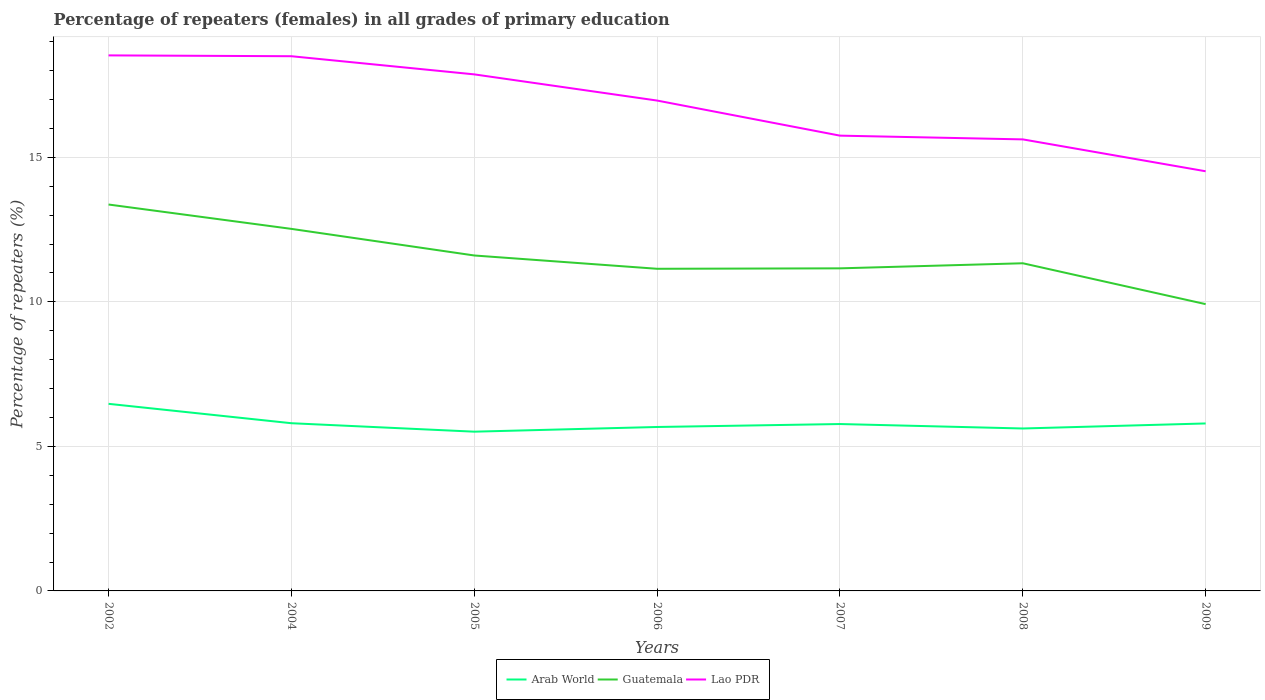How many different coloured lines are there?
Make the answer very short. 3. Is the number of lines equal to the number of legend labels?
Your answer should be very brief. Yes. Across all years, what is the maximum percentage of repeaters (females) in Arab World?
Your answer should be very brief. 5.51. What is the total percentage of repeaters (females) in Lao PDR in the graph?
Give a very brief answer. 1.23. What is the difference between the highest and the second highest percentage of repeaters (females) in Arab World?
Provide a succinct answer. 0.96. Is the percentage of repeaters (females) in Guatemala strictly greater than the percentage of repeaters (females) in Arab World over the years?
Provide a short and direct response. No. How many lines are there?
Give a very brief answer. 3. How many years are there in the graph?
Ensure brevity in your answer.  7. Does the graph contain grids?
Ensure brevity in your answer.  Yes. Where does the legend appear in the graph?
Give a very brief answer. Bottom center. What is the title of the graph?
Offer a very short reply. Percentage of repeaters (females) in all grades of primary education. What is the label or title of the Y-axis?
Make the answer very short. Percentage of repeaters (%). What is the Percentage of repeaters (%) of Arab World in 2002?
Offer a very short reply. 6.47. What is the Percentage of repeaters (%) in Guatemala in 2002?
Offer a terse response. 13.37. What is the Percentage of repeaters (%) of Lao PDR in 2002?
Offer a terse response. 18.53. What is the Percentage of repeaters (%) in Arab World in 2004?
Ensure brevity in your answer.  5.8. What is the Percentage of repeaters (%) of Guatemala in 2004?
Your answer should be compact. 12.52. What is the Percentage of repeaters (%) in Lao PDR in 2004?
Give a very brief answer. 18.5. What is the Percentage of repeaters (%) in Arab World in 2005?
Offer a terse response. 5.51. What is the Percentage of repeaters (%) in Guatemala in 2005?
Your answer should be very brief. 11.6. What is the Percentage of repeaters (%) in Lao PDR in 2005?
Keep it short and to the point. 17.87. What is the Percentage of repeaters (%) in Arab World in 2006?
Keep it short and to the point. 5.67. What is the Percentage of repeaters (%) of Guatemala in 2006?
Ensure brevity in your answer.  11.14. What is the Percentage of repeaters (%) in Lao PDR in 2006?
Give a very brief answer. 16.96. What is the Percentage of repeaters (%) of Arab World in 2007?
Your response must be concise. 5.77. What is the Percentage of repeaters (%) in Guatemala in 2007?
Provide a succinct answer. 11.16. What is the Percentage of repeaters (%) of Lao PDR in 2007?
Give a very brief answer. 15.75. What is the Percentage of repeaters (%) of Arab World in 2008?
Offer a terse response. 5.62. What is the Percentage of repeaters (%) of Guatemala in 2008?
Offer a very short reply. 11.33. What is the Percentage of repeaters (%) in Lao PDR in 2008?
Ensure brevity in your answer.  15.62. What is the Percentage of repeaters (%) in Arab World in 2009?
Provide a succinct answer. 5.79. What is the Percentage of repeaters (%) of Guatemala in 2009?
Your answer should be very brief. 9.92. What is the Percentage of repeaters (%) in Lao PDR in 2009?
Your answer should be compact. 14.52. Across all years, what is the maximum Percentage of repeaters (%) in Arab World?
Ensure brevity in your answer.  6.47. Across all years, what is the maximum Percentage of repeaters (%) of Guatemala?
Your answer should be very brief. 13.37. Across all years, what is the maximum Percentage of repeaters (%) of Lao PDR?
Ensure brevity in your answer.  18.53. Across all years, what is the minimum Percentage of repeaters (%) of Arab World?
Keep it short and to the point. 5.51. Across all years, what is the minimum Percentage of repeaters (%) in Guatemala?
Your response must be concise. 9.92. Across all years, what is the minimum Percentage of repeaters (%) of Lao PDR?
Provide a succinct answer. 14.52. What is the total Percentage of repeaters (%) of Arab World in the graph?
Your answer should be very brief. 40.64. What is the total Percentage of repeaters (%) in Guatemala in the graph?
Keep it short and to the point. 81.05. What is the total Percentage of repeaters (%) of Lao PDR in the graph?
Make the answer very short. 117.74. What is the difference between the Percentage of repeaters (%) of Arab World in 2002 and that in 2004?
Offer a terse response. 0.67. What is the difference between the Percentage of repeaters (%) in Guatemala in 2002 and that in 2004?
Offer a terse response. 0.84. What is the difference between the Percentage of repeaters (%) in Lao PDR in 2002 and that in 2004?
Make the answer very short. 0.03. What is the difference between the Percentage of repeaters (%) in Arab World in 2002 and that in 2005?
Give a very brief answer. 0.96. What is the difference between the Percentage of repeaters (%) in Guatemala in 2002 and that in 2005?
Offer a terse response. 1.76. What is the difference between the Percentage of repeaters (%) of Lao PDR in 2002 and that in 2005?
Offer a terse response. 0.66. What is the difference between the Percentage of repeaters (%) in Arab World in 2002 and that in 2006?
Your answer should be very brief. 0.8. What is the difference between the Percentage of repeaters (%) of Guatemala in 2002 and that in 2006?
Make the answer very short. 2.22. What is the difference between the Percentage of repeaters (%) of Lao PDR in 2002 and that in 2006?
Give a very brief answer. 1.56. What is the difference between the Percentage of repeaters (%) in Arab World in 2002 and that in 2007?
Keep it short and to the point. 0.7. What is the difference between the Percentage of repeaters (%) of Guatemala in 2002 and that in 2007?
Ensure brevity in your answer.  2.21. What is the difference between the Percentage of repeaters (%) in Lao PDR in 2002 and that in 2007?
Ensure brevity in your answer.  2.78. What is the difference between the Percentage of repeaters (%) of Arab World in 2002 and that in 2008?
Offer a terse response. 0.85. What is the difference between the Percentage of repeaters (%) in Guatemala in 2002 and that in 2008?
Offer a very short reply. 2.03. What is the difference between the Percentage of repeaters (%) of Lao PDR in 2002 and that in 2008?
Make the answer very short. 2.91. What is the difference between the Percentage of repeaters (%) in Arab World in 2002 and that in 2009?
Provide a succinct answer. 0.68. What is the difference between the Percentage of repeaters (%) in Guatemala in 2002 and that in 2009?
Keep it short and to the point. 3.45. What is the difference between the Percentage of repeaters (%) of Lao PDR in 2002 and that in 2009?
Give a very brief answer. 4.01. What is the difference between the Percentage of repeaters (%) in Arab World in 2004 and that in 2005?
Your answer should be very brief. 0.29. What is the difference between the Percentage of repeaters (%) in Guatemala in 2004 and that in 2005?
Keep it short and to the point. 0.92. What is the difference between the Percentage of repeaters (%) of Lao PDR in 2004 and that in 2005?
Offer a very short reply. 0.63. What is the difference between the Percentage of repeaters (%) in Arab World in 2004 and that in 2006?
Give a very brief answer. 0.13. What is the difference between the Percentage of repeaters (%) of Guatemala in 2004 and that in 2006?
Offer a terse response. 1.38. What is the difference between the Percentage of repeaters (%) of Lao PDR in 2004 and that in 2006?
Your response must be concise. 1.53. What is the difference between the Percentage of repeaters (%) in Arab World in 2004 and that in 2007?
Make the answer very short. 0.03. What is the difference between the Percentage of repeaters (%) in Guatemala in 2004 and that in 2007?
Make the answer very short. 1.37. What is the difference between the Percentage of repeaters (%) of Lao PDR in 2004 and that in 2007?
Keep it short and to the point. 2.75. What is the difference between the Percentage of repeaters (%) of Arab World in 2004 and that in 2008?
Offer a very short reply. 0.18. What is the difference between the Percentage of repeaters (%) in Guatemala in 2004 and that in 2008?
Offer a terse response. 1.19. What is the difference between the Percentage of repeaters (%) of Lao PDR in 2004 and that in 2008?
Provide a short and direct response. 2.88. What is the difference between the Percentage of repeaters (%) of Arab World in 2004 and that in 2009?
Make the answer very short. 0.01. What is the difference between the Percentage of repeaters (%) in Guatemala in 2004 and that in 2009?
Your response must be concise. 2.6. What is the difference between the Percentage of repeaters (%) in Lao PDR in 2004 and that in 2009?
Your response must be concise. 3.98. What is the difference between the Percentage of repeaters (%) in Arab World in 2005 and that in 2006?
Your response must be concise. -0.16. What is the difference between the Percentage of repeaters (%) of Guatemala in 2005 and that in 2006?
Your response must be concise. 0.46. What is the difference between the Percentage of repeaters (%) of Lao PDR in 2005 and that in 2006?
Your answer should be very brief. 0.91. What is the difference between the Percentage of repeaters (%) in Arab World in 2005 and that in 2007?
Ensure brevity in your answer.  -0.26. What is the difference between the Percentage of repeaters (%) of Guatemala in 2005 and that in 2007?
Provide a short and direct response. 0.45. What is the difference between the Percentage of repeaters (%) in Lao PDR in 2005 and that in 2007?
Your answer should be very brief. 2.12. What is the difference between the Percentage of repeaters (%) of Arab World in 2005 and that in 2008?
Provide a short and direct response. -0.11. What is the difference between the Percentage of repeaters (%) of Guatemala in 2005 and that in 2008?
Your answer should be very brief. 0.27. What is the difference between the Percentage of repeaters (%) of Lao PDR in 2005 and that in 2008?
Give a very brief answer. 2.25. What is the difference between the Percentage of repeaters (%) of Arab World in 2005 and that in 2009?
Ensure brevity in your answer.  -0.28. What is the difference between the Percentage of repeaters (%) of Guatemala in 2005 and that in 2009?
Keep it short and to the point. 1.68. What is the difference between the Percentage of repeaters (%) in Lao PDR in 2005 and that in 2009?
Give a very brief answer. 3.35. What is the difference between the Percentage of repeaters (%) of Arab World in 2006 and that in 2007?
Provide a short and direct response. -0.1. What is the difference between the Percentage of repeaters (%) in Guatemala in 2006 and that in 2007?
Your answer should be compact. -0.01. What is the difference between the Percentage of repeaters (%) of Lao PDR in 2006 and that in 2007?
Ensure brevity in your answer.  1.21. What is the difference between the Percentage of repeaters (%) of Arab World in 2006 and that in 2008?
Offer a very short reply. 0.05. What is the difference between the Percentage of repeaters (%) in Guatemala in 2006 and that in 2008?
Make the answer very short. -0.19. What is the difference between the Percentage of repeaters (%) in Lao PDR in 2006 and that in 2008?
Provide a short and direct response. 1.34. What is the difference between the Percentage of repeaters (%) in Arab World in 2006 and that in 2009?
Your response must be concise. -0.12. What is the difference between the Percentage of repeaters (%) in Guatemala in 2006 and that in 2009?
Your answer should be compact. 1.22. What is the difference between the Percentage of repeaters (%) of Lao PDR in 2006 and that in 2009?
Your answer should be compact. 2.45. What is the difference between the Percentage of repeaters (%) of Arab World in 2007 and that in 2008?
Provide a succinct answer. 0.15. What is the difference between the Percentage of repeaters (%) of Guatemala in 2007 and that in 2008?
Give a very brief answer. -0.18. What is the difference between the Percentage of repeaters (%) in Lao PDR in 2007 and that in 2008?
Provide a short and direct response. 0.13. What is the difference between the Percentage of repeaters (%) of Arab World in 2007 and that in 2009?
Offer a terse response. -0.02. What is the difference between the Percentage of repeaters (%) of Guatemala in 2007 and that in 2009?
Your response must be concise. 1.24. What is the difference between the Percentage of repeaters (%) in Lao PDR in 2007 and that in 2009?
Your answer should be very brief. 1.23. What is the difference between the Percentage of repeaters (%) of Arab World in 2008 and that in 2009?
Your response must be concise. -0.17. What is the difference between the Percentage of repeaters (%) of Guatemala in 2008 and that in 2009?
Provide a succinct answer. 1.41. What is the difference between the Percentage of repeaters (%) of Lao PDR in 2008 and that in 2009?
Ensure brevity in your answer.  1.1. What is the difference between the Percentage of repeaters (%) of Arab World in 2002 and the Percentage of repeaters (%) of Guatemala in 2004?
Ensure brevity in your answer.  -6.05. What is the difference between the Percentage of repeaters (%) of Arab World in 2002 and the Percentage of repeaters (%) of Lao PDR in 2004?
Keep it short and to the point. -12.02. What is the difference between the Percentage of repeaters (%) of Guatemala in 2002 and the Percentage of repeaters (%) of Lao PDR in 2004?
Your answer should be compact. -5.13. What is the difference between the Percentage of repeaters (%) of Arab World in 2002 and the Percentage of repeaters (%) of Guatemala in 2005?
Make the answer very short. -5.13. What is the difference between the Percentage of repeaters (%) of Arab World in 2002 and the Percentage of repeaters (%) of Lao PDR in 2005?
Offer a very short reply. -11.4. What is the difference between the Percentage of repeaters (%) of Guatemala in 2002 and the Percentage of repeaters (%) of Lao PDR in 2005?
Give a very brief answer. -4.5. What is the difference between the Percentage of repeaters (%) of Arab World in 2002 and the Percentage of repeaters (%) of Guatemala in 2006?
Ensure brevity in your answer.  -4.67. What is the difference between the Percentage of repeaters (%) of Arab World in 2002 and the Percentage of repeaters (%) of Lao PDR in 2006?
Keep it short and to the point. -10.49. What is the difference between the Percentage of repeaters (%) in Guatemala in 2002 and the Percentage of repeaters (%) in Lao PDR in 2006?
Provide a succinct answer. -3.6. What is the difference between the Percentage of repeaters (%) of Arab World in 2002 and the Percentage of repeaters (%) of Guatemala in 2007?
Your answer should be compact. -4.69. What is the difference between the Percentage of repeaters (%) of Arab World in 2002 and the Percentage of repeaters (%) of Lao PDR in 2007?
Your response must be concise. -9.28. What is the difference between the Percentage of repeaters (%) of Guatemala in 2002 and the Percentage of repeaters (%) of Lao PDR in 2007?
Your answer should be very brief. -2.38. What is the difference between the Percentage of repeaters (%) in Arab World in 2002 and the Percentage of repeaters (%) in Guatemala in 2008?
Keep it short and to the point. -4.86. What is the difference between the Percentage of repeaters (%) of Arab World in 2002 and the Percentage of repeaters (%) of Lao PDR in 2008?
Provide a short and direct response. -9.15. What is the difference between the Percentage of repeaters (%) of Guatemala in 2002 and the Percentage of repeaters (%) of Lao PDR in 2008?
Make the answer very short. -2.25. What is the difference between the Percentage of repeaters (%) in Arab World in 2002 and the Percentage of repeaters (%) in Guatemala in 2009?
Keep it short and to the point. -3.45. What is the difference between the Percentage of repeaters (%) of Arab World in 2002 and the Percentage of repeaters (%) of Lao PDR in 2009?
Your response must be concise. -8.04. What is the difference between the Percentage of repeaters (%) of Guatemala in 2002 and the Percentage of repeaters (%) of Lao PDR in 2009?
Keep it short and to the point. -1.15. What is the difference between the Percentage of repeaters (%) in Arab World in 2004 and the Percentage of repeaters (%) in Guatemala in 2005?
Offer a very short reply. -5.8. What is the difference between the Percentage of repeaters (%) of Arab World in 2004 and the Percentage of repeaters (%) of Lao PDR in 2005?
Offer a very short reply. -12.07. What is the difference between the Percentage of repeaters (%) of Guatemala in 2004 and the Percentage of repeaters (%) of Lao PDR in 2005?
Your answer should be very brief. -5.34. What is the difference between the Percentage of repeaters (%) in Arab World in 2004 and the Percentage of repeaters (%) in Guatemala in 2006?
Make the answer very short. -5.34. What is the difference between the Percentage of repeaters (%) of Arab World in 2004 and the Percentage of repeaters (%) of Lao PDR in 2006?
Provide a short and direct response. -11.16. What is the difference between the Percentage of repeaters (%) in Guatemala in 2004 and the Percentage of repeaters (%) in Lao PDR in 2006?
Offer a terse response. -4.44. What is the difference between the Percentage of repeaters (%) in Arab World in 2004 and the Percentage of repeaters (%) in Guatemala in 2007?
Provide a short and direct response. -5.36. What is the difference between the Percentage of repeaters (%) of Arab World in 2004 and the Percentage of repeaters (%) of Lao PDR in 2007?
Your answer should be very brief. -9.95. What is the difference between the Percentage of repeaters (%) in Guatemala in 2004 and the Percentage of repeaters (%) in Lao PDR in 2007?
Your response must be concise. -3.23. What is the difference between the Percentage of repeaters (%) of Arab World in 2004 and the Percentage of repeaters (%) of Guatemala in 2008?
Keep it short and to the point. -5.53. What is the difference between the Percentage of repeaters (%) in Arab World in 2004 and the Percentage of repeaters (%) in Lao PDR in 2008?
Your answer should be very brief. -9.82. What is the difference between the Percentage of repeaters (%) in Guatemala in 2004 and the Percentage of repeaters (%) in Lao PDR in 2008?
Make the answer very short. -3.1. What is the difference between the Percentage of repeaters (%) in Arab World in 2004 and the Percentage of repeaters (%) in Guatemala in 2009?
Your response must be concise. -4.12. What is the difference between the Percentage of repeaters (%) of Arab World in 2004 and the Percentage of repeaters (%) of Lao PDR in 2009?
Your answer should be very brief. -8.72. What is the difference between the Percentage of repeaters (%) of Guatemala in 2004 and the Percentage of repeaters (%) of Lao PDR in 2009?
Provide a short and direct response. -1.99. What is the difference between the Percentage of repeaters (%) of Arab World in 2005 and the Percentage of repeaters (%) of Guatemala in 2006?
Your answer should be very brief. -5.63. What is the difference between the Percentage of repeaters (%) in Arab World in 2005 and the Percentage of repeaters (%) in Lao PDR in 2006?
Provide a succinct answer. -11.45. What is the difference between the Percentage of repeaters (%) of Guatemala in 2005 and the Percentage of repeaters (%) of Lao PDR in 2006?
Your response must be concise. -5.36. What is the difference between the Percentage of repeaters (%) in Arab World in 2005 and the Percentage of repeaters (%) in Guatemala in 2007?
Make the answer very short. -5.65. What is the difference between the Percentage of repeaters (%) of Arab World in 2005 and the Percentage of repeaters (%) of Lao PDR in 2007?
Offer a very short reply. -10.24. What is the difference between the Percentage of repeaters (%) in Guatemala in 2005 and the Percentage of repeaters (%) in Lao PDR in 2007?
Your response must be concise. -4.15. What is the difference between the Percentage of repeaters (%) of Arab World in 2005 and the Percentage of repeaters (%) of Guatemala in 2008?
Offer a very short reply. -5.83. What is the difference between the Percentage of repeaters (%) in Arab World in 2005 and the Percentage of repeaters (%) in Lao PDR in 2008?
Provide a short and direct response. -10.11. What is the difference between the Percentage of repeaters (%) in Guatemala in 2005 and the Percentage of repeaters (%) in Lao PDR in 2008?
Your answer should be compact. -4.02. What is the difference between the Percentage of repeaters (%) in Arab World in 2005 and the Percentage of repeaters (%) in Guatemala in 2009?
Offer a very short reply. -4.41. What is the difference between the Percentage of repeaters (%) in Arab World in 2005 and the Percentage of repeaters (%) in Lao PDR in 2009?
Provide a succinct answer. -9.01. What is the difference between the Percentage of repeaters (%) in Guatemala in 2005 and the Percentage of repeaters (%) in Lao PDR in 2009?
Your response must be concise. -2.91. What is the difference between the Percentage of repeaters (%) of Arab World in 2006 and the Percentage of repeaters (%) of Guatemala in 2007?
Your answer should be compact. -5.49. What is the difference between the Percentage of repeaters (%) of Arab World in 2006 and the Percentage of repeaters (%) of Lao PDR in 2007?
Your answer should be very brief. -10.08. What is the difference between the Percentage of repeaters (%) of Guatemala in 2006 and the Percentage of repeaters (%) of Lao PDR in 2007?
Provide a succinct answer. -4.61. What is the difference between the Percentage of repeaters (%) in Arab World in 2006 and the Percentage of repeaters (%) in Guatemala in 2008?
Make the answer very short. -5.66. What is the difference between the Percentage of repeaters (%) in Arab World in 2006 and the Percentage of repeaters (%) in Lao PDR in 2008?
Offer a very short reply. -9.95. What is the difference between the Percentage of repeaters (%) of Guatemala in 2006 and the Percentage of repeaters (%) of Lao PDR in 2008?
Your answer should be very brief. -4.48. What is the difference between the Percentage of repeaters (%) of Arab World in 2006 and the Percentage of repeaters (%) of Guatemala in 2009?
Offer a very short reply. -4.25. What is the difference between the Percentage of repeaters (%) of Arab World in 2006 and the Percentage of repeaters (%) of Lao PDR in 2009?
Provide a succinct answer. -8.85. What is the difference between the Percentage of repeaters (%) of Guatemala in 2006 and the Percentage of repeaters (%) of Lao PDR in 2009?
Provide a short and direct response. -3.37. What is the difference between the Percentage of repeaters (%) in Arab World in 2007 and the Percentage of repeaters (%) in Guatemala in 2008?
Keep it short and to the point. -5.56. What is the difference between the Percentage of repeaters (%) of Arab World in 2007 and the Percentage of repeaters (%) of Lao PDR in 2008?
Your answer should be compact. -9.85. What is the difference between the Percentage of repeaters (%) in Guatemala in 2007 and the Percentage of repeaters (%) in Lao PDR in 2008?
Keep it short and to the point. -4.46. What is the difference between the Percentage of repeaters (%) of Arab World in 2007 and the Percentage of repeaters (%) of Guatemala in 2009?
Your answer should be very brief. -4.15. What is the difference between the Percentage of repeaters (%) of Arab World in 2007 and the Percentage of repeaters (%) of Lao PDR in 2009?
Your answer should be compact. -8.74. What is the difference between the Percentage of repeaters (%) in Guatemala in 2007 and the Percentage of repeaters (%) in Lao PDR in 2009?
Make the answer very short. -3.36. What is the difference between the Percentage of repeaters (%) of Arab World in 2008 and the Percentage of repeaters (%) of Guatemala in 2009?
Offer a terse response. -4.3. What is the difference between the Percentage of repeaters (%) of Arab World in 2008 and the Percentage of repeaters (%) of Lao PDR in 2009?
Ensure brevity in your answer.  -8.9. What is the difference between the Percentage of repeaters (%) in Guatemala in 2008 and the Percentage of repeaters (%) in Lao PDR in 2009?
Your response must be concise. -3.18. What is the average Percentage of repeaters (%) in Arab World per year?
Your answer should be compact. 5.81. What is the average Percentage of repeaters (%) of Guatemala per year?
Offer a terse response. 11.58. What is the average Percentage of repeaters (%) of Lao PDR per year?
Offer a very short reply. 16.82. In the year 2002, what is the difference between the Percentage of repeaters (%) in Arab World and Percentage of repeaters (%) in Guatemala?
Make the answer very short. -6.89. In the year 2002, what is the difference between the Percentage of repeaters (%) in Arab World and Percentage of repeaters (%) in Lao PDR?
Provide a short and direct response. -12.05. In the year 2002, what is the difference between the Percentage of repeaters (%) of Guatemala and Percentage of repeaters (%) of Lao PDR?
Keep it short and to the point. -5.16. In the year 2004, what is the difference between the Percentage of repeaters (%) in Arab World and Percentage of repeaters (%) in Guatemala?
Make the answer very short. -6.72. In the year 2004, what is the difference between the Percentage of repeaters (%) in Arab World and Percentage of repeaters (%) in Lao PDR?
Ensure brevity in your answer.  -12.7. In the year 2004, what is the difference between the Percentage of repeaters (%) in Guatemala and Percentage of repeaters (%) in Lao PDR?
Give a very brief answer. -5.97. In the year 2005, what is the difference between the Percentage of repeaters (%) of Arab World and Percentage of repeaters (%) of Guatemala?
Your response must be concise. -6.09. In the year 2005, what is the difference between the Percentage of repeaters (%) in Arab World and Percentage of repeaters (%) in Lao PDR?
Your answer should be compact. -12.36. In the year 2005, what is the difference between the Percentage of repeaters (%) of Guatemala and Percentage of repeaters (%) of Lao PDR?
Your response must be concise. -6.26. In the year 2006, what is the difference between the Percentage of repeaters (%) of Arab World and Percentage of repeaters (%) of Guatemala?
Ensure brevity in your answer.  -5.47. In the year 2006, what is the difference between the Percentage of repeaters (%) of Arab World and Percentage of repeaters (%) of Lao PDR?
Your response must be concise. -11.29. In the year 2006, what is the difference between the Percentage of repeaters (%) in Guatemala and Percentage of repeaters (%) in Lao PDR?
Provide a short and direct response. -5.82. In the year 2007, what is the difference between the Percentage of repeaters (%) in Arab World and Percentage of repeaters (%) in Guatemala?
Offer a very short reply. -5.39. In the year 2007, what is the difference between the Percentage of repeaters (%) in Arab World and Percentage of repeaters (%) in Lao PDR?
Provide a succinct answer. -9.98. In the year 2007, what is the difference between the Percentage of repeaters (%) in Guatemala and Percentage of repeaters (%) in Lao PDR?
Make the answer very short. -4.59. In the year 2008, what is the difference between the Percentage of repeaters (%) in Arab World and Percentage of repeaters (%) in Guatemala?
Give a very brief answer. -5.72. In the year 2008, what is the difference between the Percentage of repeaters (%) in Arab World and Percentage of repeaters (%) in Lao PDR?
Provide a short and direct response. -10. In the year 2008, what is the difference between the Percentage of repeaters (%) in Guatemala and Percentage of repeaters (%) in Lao PDR?
Provide a succinct answer. -4.29. In the year 2009, what is the difference between the Percentage of repeaters (%) of Arab World and Percentage of repeaters (%) of Guatemala?
Provide a succinct answer. -4.13. In the year 2009, what is the difference between the Percentage of repeaters (%) of Arab World and Percentage of repeaters (%) of Lao PDR?
Keep it short and to the point. -8.72. In the year 2009, what is the difference between the Percentage of repeaters (%) of Guatemala and Percentage of repeaters (%) of Lao PDR?
Your answer should be compact. -4.6. What is the ratio of the Percentage of repeaters (%) of Arab World in 2002 to that in 2004?
Make the answer very short. 1.12. What is the ratio of the Percentage of repeaters (%) in Guatemala in 2002 to that in 2004?
Offer a very short reply. 1.07. What is the ratio of the Percentage of repeaters (%) of Lao PDR in 2002 to that in 2004?
Keep it short and to the point. 1. What is the ratio of the Percentage of repeaters (%) of Arab World in 2002 to that in 2005?
Offer a very short reply. 1.17. What is the ratio of the Percentage of repeaters (%) of Guatemala in 2002 to that in 2005?
Your response must be concise. 1.15. What is the ratio of the Percentage of repeaters (%) in Lao PDR in 2002 to that in 2005?
Give a very brief answer. 1.04. What is the ratio of the Percentage of repeaters (%) in Arab World in 2002 to that in 2006?
Your response must be concise. 1.14. What is the ratio of the Percentage of repeaters (%) of Guatemala in 2002 to that in 2006?
Offer a very short reply. 1.2. What is the ratio of the Percentage of repeaters (%) in Lao PDR in 2002 to that in 2006?
Make the answer very short. 1.09. What is the ratio of the Percentage of repeaters (%) in Arab World in 2002 to that in 2007?
Provide a short and direct response. 1.12. What is the ratio of the Percentage of repeaters (%) of Guatemala in 2002 to that in 2007?
Provide a short and direct response. 1.2. What is the ratio of the Percentage of repeaters (%) in Lao PDR in 2002 to that in 2007?
Offer a terse response. 1.18. What is the ratio of the Percentage of repeaters (%) of Arab World in 2002 to that in 2008?
Offer a very short reply. 1.15. What is the ratio of the Percentage of repeaters (%) in Guatemala in 2002 to that in 2008?
Give a very brief answer. 1.18. What is the ratio of the Percentage of repeaters (%) in Lao PDR in 2002 to that in 2008?
Your answer should be very brief. 1.19. What is the ratio of the Percentage of repeaters (%) in Arab World in 2002 to that in 2009?
Your answer should be compact. 1.12. What is the ratio of the Percentage of repeaters (%) of Guatemala in 2002 to that in 2009?
Keep it short and to the point. 1.35. What is the ratio of the Percentage of repeaters (%) in Lao PDR in 2002 to that in 2009?
Your answer should be compact. 1.28. What is the ratio of the Percentage of repeaters (%) of Arab World in 2004 to that in 2005?
Your response must be concise. 1.05. What is the ratio of the Percentage of repeaters (%) of Guatemala in 2004 to that in 2005?
Offer a very short reply. 1.08. What is the ratio of the Percentage of repeaters (%) in Lao PDR in 2004 to that in 2005?
Provide a short and direct response. 1.04. What is the ratio of the Percentage of repeaters (%) of Arab World in 2004 to that in 2006?
Your answer should be compact. 1.02. What is the ratio of the Percentage of repeaters (%) in Guatemala in 2004 to that in 2006?
Give a very brief answer. 1.12. What is the ratio of the Percentage of repeaters (%) of Lao PDR in 2004 to that in 2006?
Make the answer very short. 1.09. What is the ratio of the Percentage of repeaters (%) in Guatemala in 2004 to that in 2007?
Your answer should be very brief. 1.12. What is the ratio of the Percentage of repeaters (%) in Lao PDR in 2004 to that in 2007?
Give a very brief answer. 1.17. What is the ratio of the Percentage of repeaters (%) in Arab World in 2004 to that in 2008?
Offer a very short reply. 1.03. What is the ratio of the Percentage of repeaters (%) in Guatemala in 2004 to that in 2008?
Ensure brevity in your answer.  1.1. What is the ratio of the Percentage of repeaters (%) in Lao PDR in 2004 to that in 2008?
Your answer should be very brief. 1.18. What is the ratio of the Percentage of repeaters (%) in Arab World in 2004 to that in 2009?
Offer a terse response. 1. What is the ratio of the Percentage of repeaters (%) in Guatemala in 2004 to that in 2009?
Ensure brevity in your answer.  1.26. What is the ratio of the Percentage of repeaters (%) in Lao PDR in 2004 to that in 2009?
Offer a very short reply. 1.27. What is the ratio of the Percentage of repeaters (%) in Arab World in 2005 to that in 2006?
Give a very brief answer. 0.97. What is the ratio of the Percentage of repeaters (%) in Guatemala in 2005 to that in 2006?
Give a very brief answer. 1.04. What is the ratio of the Percentage of repeaters (%) of Lao PDR in 2005 to that in 2006?
Offer a terse response. 1.05. What is the ratio of the Percentage of repeaters (%) of Arab World in 2005 to that in 2007?
Your answer should be very brief. 0.95. What is the ratio of the Percentage of repeaters (%) of Guatemala in 2005 to that in 2007?
Your answer should be compact. 1.04. What is the ratio of the Percentage of repeaters (%) of Lao PDR in 2005 to that in 2007?
Your answer should be compact. 1.13. What is the ratio of the Percentage of repeaters (%) of Arab World in 2005 to that in 2008?
Ensure brevity in your answer.  0.98. What is the ratio of the Percentage of repeaters (%) of Guatemala in 2005 to that in 2008?
Your answer should be compact. 1.02. What is the ratio of the Percentage of repeaters (%) in Lao PDR in 2005 to that in 2008?
Give a very brief answer. 1.14. What is the ratio of the Percentage of repeaters (%) in Arab World in 2005 to that in 2009?
Give a very brief answer. 0.95. What is the ratio of the Percentage of repeaters (%) in Guatemala in 2005 to that in 2009?
Provide a succinct answer. 1.17. What is the ratio of the Percentage of repeaters (%) of Lao PDR in 2005 to that in 2009?
Offer a terse response. 1.23. What is the ratio of the Percentage of repeaters (%) in Arab World in 2006 to that in 2007?
Provide a succinct answer. 0.98. What is the ratio of the Percentage of repeaters (%) in Lao PDR in 2006 to that in 2007?
Give a very brief answer. 1.08. What is the ratio of the Percentage of repeaters (%) of Arab World in 2006 to that in 2008?
Offer a terse response. 1.01. What is the ratio of the Percentage of repeaters (%) of Guatemala in 2006 to that in 2008?
Offer a terse response. 0.98. What is the ratio of the Percentage of repeaters (%) of Lao PDR in 2006 to that in 2008?
Keep it short and to the point. 1.09. What is the ratio of the Percentage of repeaters (%) of Arab World in 2006 to that in 2009?
Your answer should be compact. 0.98. What is the ratio of the Percentage of repeaters (%) in Guatemala in 2006 to that in 2009?
Provide a short and direct response. 1.12. What is the ratio of the Percentage of repeaters (%) of Lao PDR in 2006 to that in 2009?
Make the answer very short. 1.17. What is the ratio of the Percentage of repeaters (%) of Arab World in 2007 to that in 2008?
Offer a very short reply. 1.03. What is the ratio of the Percentage of repeaters (%) of Guatemala in 2007 to that in 2008?
Your answer should be very brief. 0.98. What is the ratio of the Percentage of repeaters (%) in Lao PDR in 2007 to that in 2008?
Ensure brevity in your answer.  1.01. What is the ratio of the Percentage of repeaters (%) in Guatemala in 2007 to that in 2009?
Ensure brevity in your answer.  1.12. What is the ratio of the Percentage of repeaters (%) in Lao PDR in 2007 to that in 2009?
Provide a short and direct response. 1.08. What is the ratio of the Percentage of repeaters (%) in Arab World in 2008 to that in 2009?
Your answer should be very brief. 0.97. What is the ratio of the Percentage of repeaters (%) in Guatemala in 2008 to that in 2009?
Provide a succinct answer. 1.14. What is the ratio of the Percentage of repeaters (%) in Lao PDR in 2008 to that in 2009?
Make the answer very short. 1.08. What is the difference between the highest and the second highest Percentage of repeaters (%) in Arab World?
Provide a succinct answer. 0.67. What is the difference between the highest and the second highest Percentage of repeaters (%) of Guatemala?
Provide a succinct answer. 0.84. What is the difference between the highest and the second highest Percentage of repeaters (%) in Lao PDR?
Provide a short and direct response. 0.03. What is the difference between the highest and the lowest Percentage of repeaters (%) in Arab World?
Your answer should be compact. 0.96. What is the difference between the highest and the lowest Percentage of repeaters (%) in Guatemala?
Your response must be concise. 3.45. What is the difference between the highest and the lowest Percentage of repeaters (%) in Lao PDR?
Keep it short and to the point. 4.01. 